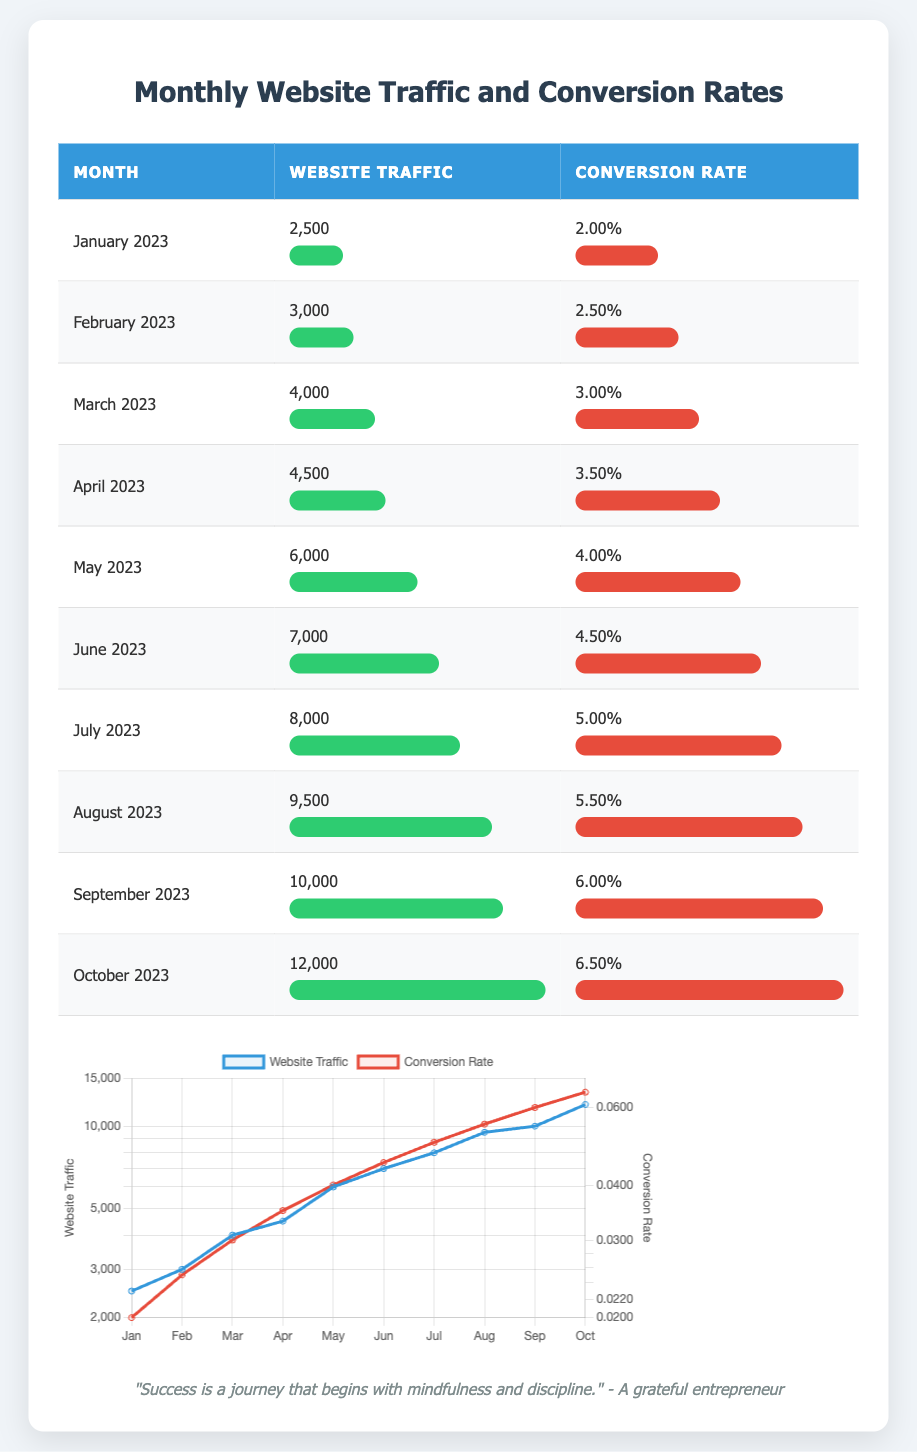What was the website traffic in May 2023? The table shows that the website traffic for May 2023 is listed under the corresponding month, which states 6000.
Answer: 6000 What is the conversion rate for April 2023? Referring to the row for April 2023 in the table, the conversion rate is mentioned as 0.035.
Answer: 0.035 Was the conversion rate higher in June 2023 than in January 2023? The conversion rate for June 2023 is 0.045 and for January 2023 is 0.02. Since 0.045 is greater than 0.02, the conversion rate in June 2023 was higher.
Answer: Yes What is the average website traffic from January to March 2023? The website traffic for January is 2500, February is 3000, and March is 4000. To find the average: (2500 + 3000 + 4000) = 9500, then divide by 3 which gives 9500/3 = approximately 3166.67.
Answer: Approximately 3166.67 How much did the website traffic increase from February to March 2023? The website traffic in February 2023 is 3000 and in March 2023 is 4000. The increase is calculated as 4000 - 3000 = 1000.
Answer: 1000 Was the total website traffic in the first half of 2023 (January to June) more or less than 30,000? First, sum the website traffic for January (2500), February (3000), March (4000), April (4500), May (6000), and June (7000): 2500 + 3000 + 4000 + 4500 + 6000 + 7000 = 27000. The total is less than 30,000.
Answer: Less What was the maximum conversion rate observed in 2023? By examining each conversion rate listed by month, the rates are 0.02, 0.025, 0.03, 0.035, 0.04, 0.045, 0.05, 0.055, 0.06, and 0.065. The maximum value among these is 0.065 for October 2023.
Answer: 0.065 How many months showed a conversion rate greater than 0.04? The conversion rates above 0.04 are from May (0.04), June (0.045), July (0.05), August (0.055), September (0.06), and October (0.065). This totals to 6 months.
Answer: 6 Which month had the highest website traffic, and what was that value? The table clearly indicates October 2023 had the highest website traffic listed as 12000.
Answer: October 2023, 12000 